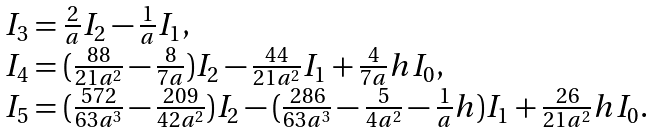<formula> <loc_0><loc_0><loc_500><loc_500>\begin{array} { l } I _ { 3 } = \frac { 2 } { a } I _ { 2 } - \frac { 1 } { a } I _ { 1 } , \\ I _ { 4 } = ( \frac { 8 8 } { 2 1 a ^ { 2 } } - \frac { 8 } { 7 a } ) I _ { 2 } - \frac { 4 4 } { 2 1 a ^ { 2 } } I _ { 1 } + \frac { 4 } { 7 a } h I _ { 0 } , \\ I _ { 5 } = ( \frac { 5 7 2 } { 6 3 a ^ { 3 } } - \frac { 2 0 9 } { 4 2 a ^ { 2 } } ) I _ { 2 } - ( \frac { 2 8 6 } { 6 3 a ^ { 3 } } - \frac { 5 } { 4 a ^ { 2 } } - \frac { 1 } { a } h ) I _ { 1 } + \frac { 2 6 } { 2 1 a ^ { 2 } } h I _ { 0 } . \end{array}</formula> 